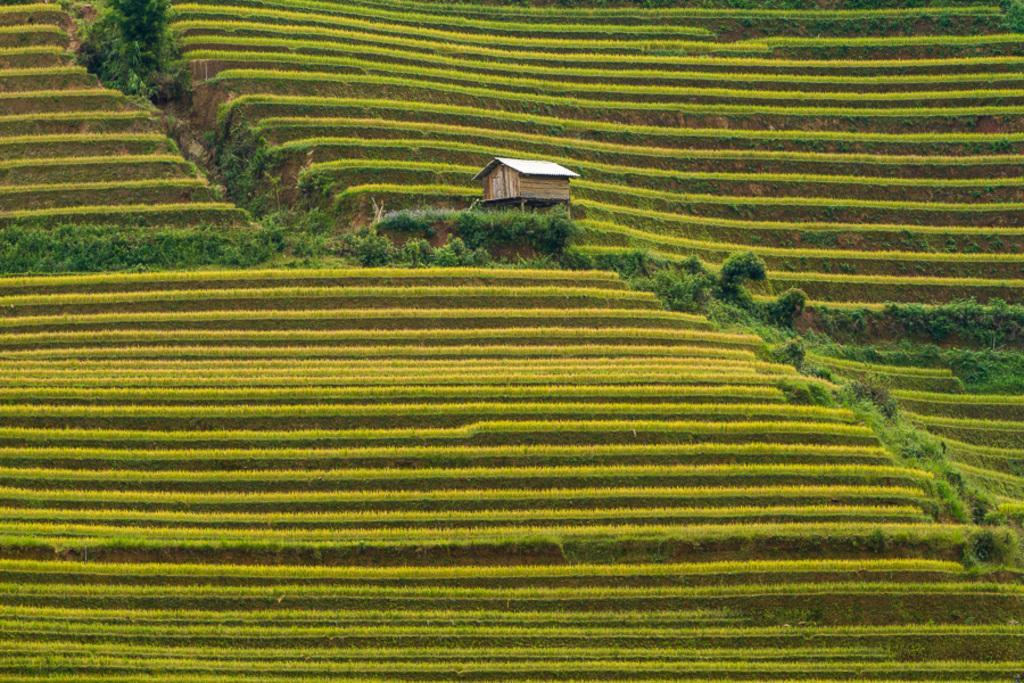Describe this image in one or two sentences. This is the step farming. I can see small bushes. This looks like a small wooden house. 